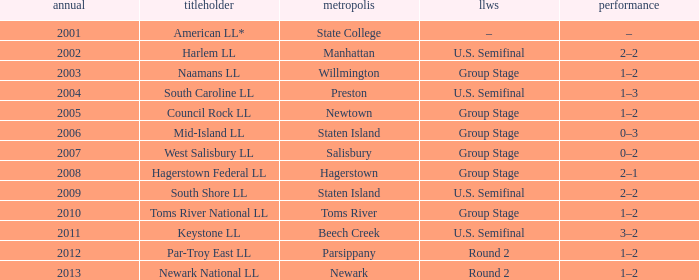Which Little League World Series took place in Parsippany? Round 2. 